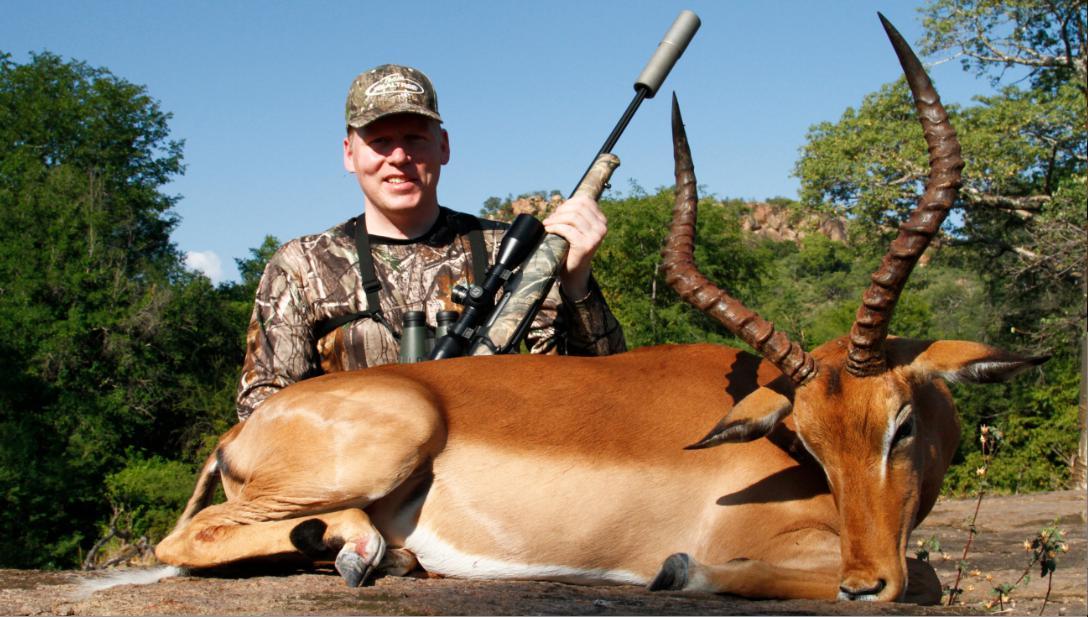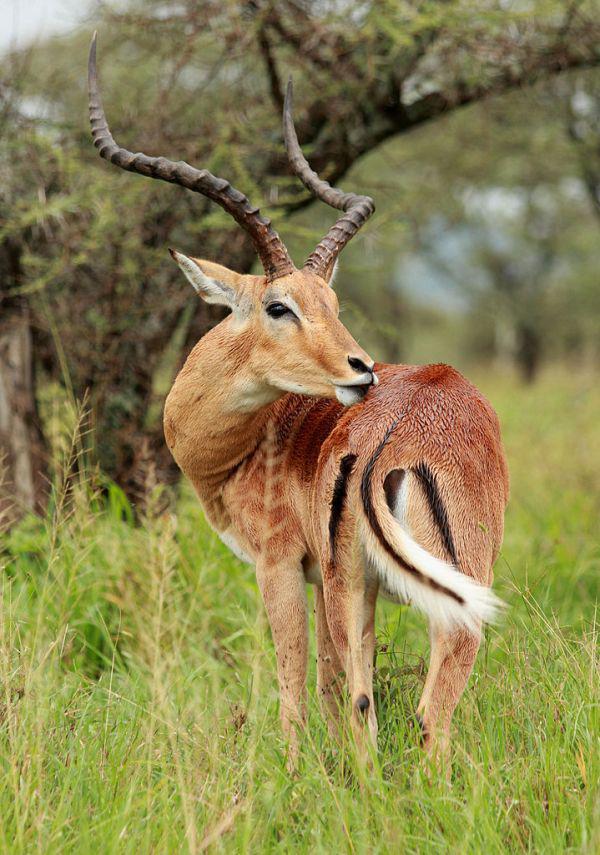The first image is the image on the left, the second image is the image on the right. Analyze the images presented: Is the assertion "You can see a second animal further off in the background." valid? Answer yes or no. No. 